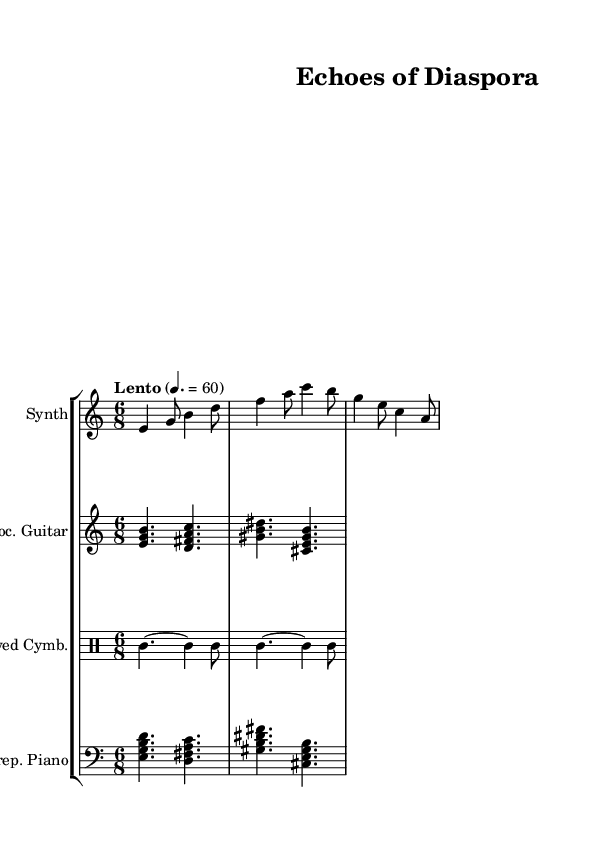What is the time signature of this piece? The time signature is indicated at the beginning of the piece as 6/8, meaning there are six eighth notes per measure.
Answer: 6/8 What is the tempo marking provided? The tempo marking is stated as "Lento" with a metronome mark of 60, indicating a slow tempo.
Answer: Lento, 60 How many instruments are featured in this score? By counting the distinct staves in the score, there are four instruments: Synth, Processed Guitar, Bowed Cymbals, and Prepared Piano.
Answer: Four What is the clef used for the synthesizer? The clef for the synthesizer part is the treble clef, which is indicated at the beginning of that staff.
Answer: Treble Which musical instrument is indicated to use percussion clef? The Bowed Cymbals section is specified to use the percussion clef, visible at the beginning of that staff.
Answer: Percussion In what register is the prepared piano written? The prepared piano part is written in the bass clef, which typically indicates lower registers for instruments.
Answer: Bass clef What dynamic characterizes the overall feel of this soundtrack? The piece's character is likely atmospheric and ambient, suggested by the combination of synth and prepared piano, meant to evoke a sense of reflection on cultural identity.
Answer: Atmospheric 